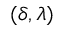<formula> <loc_0><loc_0><loc_500><loc_500>( \delta , \lambda )</formula> 